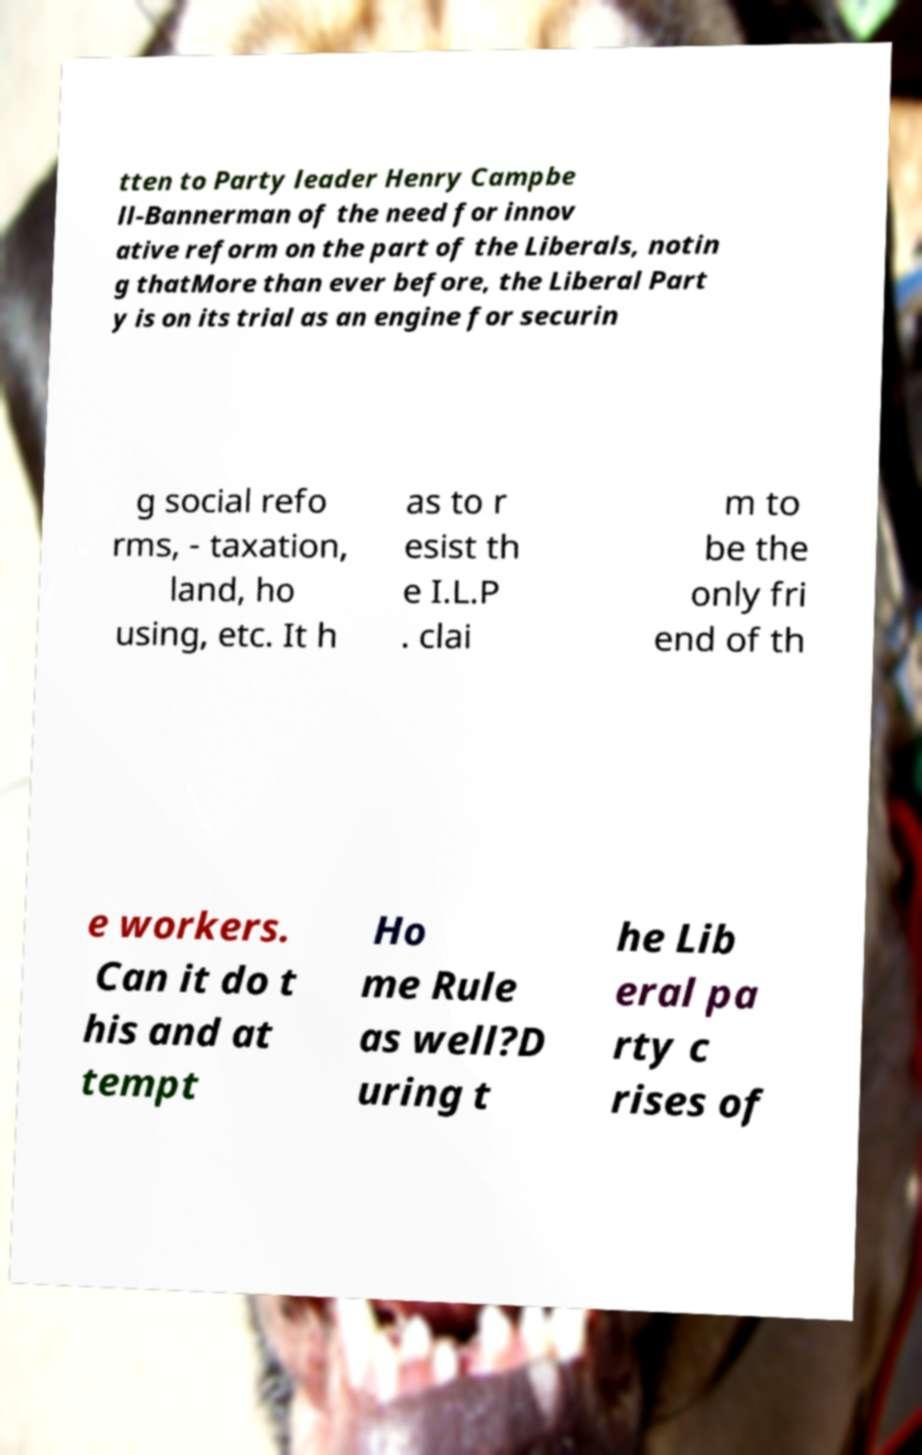Can you read and provide the text displayed in the image?This photo seems to have some interesting text. Can you extract and type it out for me? tten to Party leader Henry Campbe ll-Bannerman of the need for innov ative reform on the part of the Liberals, notin g thatMore than ever before, the Liberal Part y is on its trial as an engine for securin g social refo rms, - taxation, land, ho using, etc. It h as to r esist th e I.L.P . clai m to be the only fri end of th e workers. Can it do t his and at tempt Ho me Rule as well?D uring t he Lib eral pa rty c rises of 